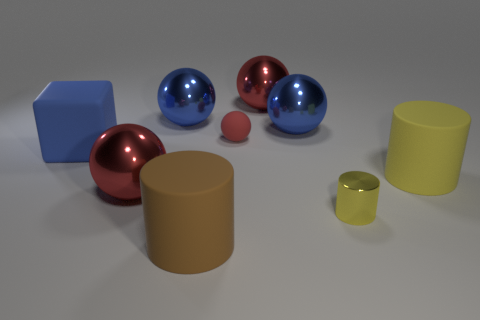Do the large brown thing and the yellow cylinder that is to the right of the small yellow object have the same material?
Offer a very short reply. Yes. The large object in front of the small shiny cylinder that is in front of the big matte cube is what shape?
Give a very brief answer. Cylinder. The blue object that is both behind the matte ball and on the left side of the large brown cylinder has what shape?
Provide a short and direct response. Sphere. What number of things are either tiny balls or large blue things behind the matte sphere?
Provide a short and direct response. 3. There is a small yellow object that is the same shape as the large brown object; what is it made of?
Ensure brevity in your answer.  Metal. Is there anything else that has the same material as the tiny red object?
Keep it short and to the point. Yes. What is the large object that is both in front of the red matte object and behind the large yellow object made of?
Offer a very short reply. Rubber. How many other brown things are the same shape as the small metallic thing?
Offer a very short reply. 1. What color is the large sphere in front of the blue matte thing in front of the matte ball?
Your answer should be very brief. Red. Are there the same number of metallic balls behind the yellow rubber cylinder and yellow matte objects?
Offer a terse response. No. 